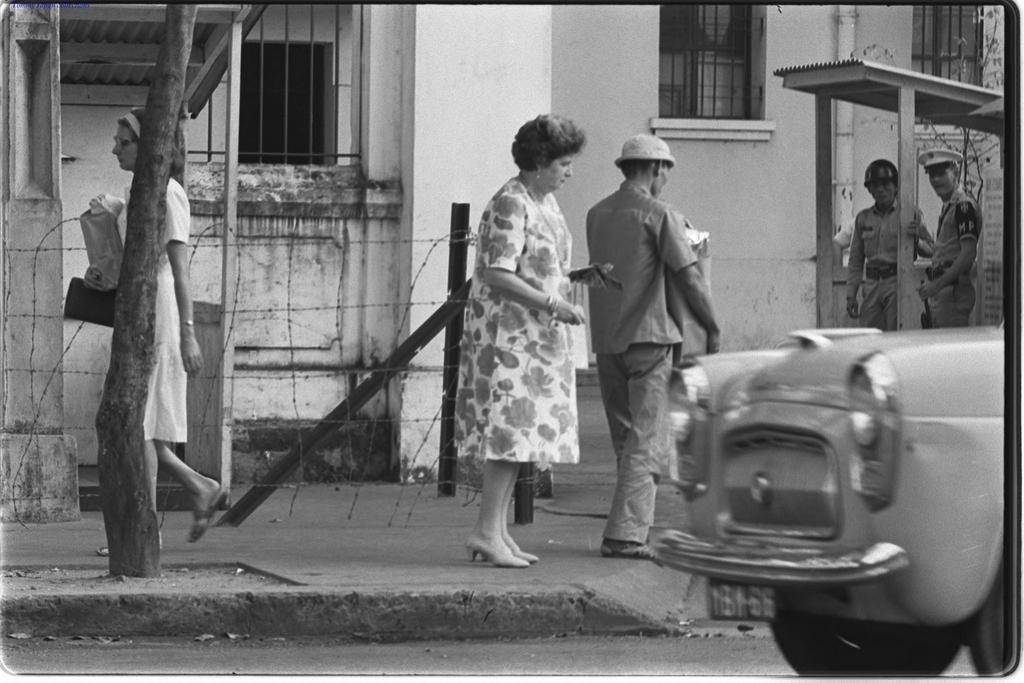How many people can be seen in the image? There are people in the image, but the exact number cannot be determined from the provided facts. What type of vehicle is on the road in the image? The facts do not specify the type of vehicle on the road. What is the purpose of the fence in the image? The purpose of the fence cannot be determined from the provided facts. What is the shed used for in the image? The facts do not specify the purpose of the shed. What type of tree is in the image? The facts do not specify the type of tree. What can be seen in the background of the image? In the background of the image, there are walls and windows visible. What type of quartz can be seen in the image? There is no quartz present in the image. Can you hear a whistle in the image? There is no mention of a whistle in the image, so it cannot be heard. Are there any fish visible in the image? There is no mention of fish in the image, so they cannot be seen. 